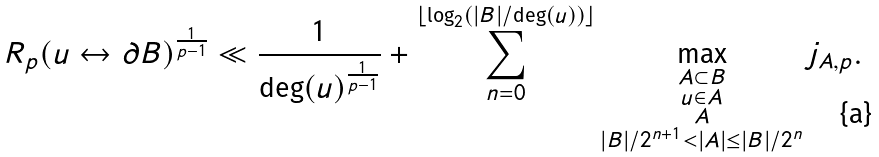<formula> <loc_0><loc_0><loc_500><loc_500>R _ { p } ( u \leftrightarrow \partial B ) ^ { \frac { 1 } { p - 1 } } \ll \frac { 1 } { \deg ( u ) ^ { \frac { 1 } { p - 1 } } } + \sum _ { n = 0 } ^ { \lfloor \log _ { 2 } ( | B | / \deg ( u ) ) \rfloor } \max _ { \substack { A \subset B \\ u \in A \\ A \\ | B | / 2 ^ { n + 1 } < | A | \leq | B | / 2 ^ { n } } } j _ { A , p } .</formula> 